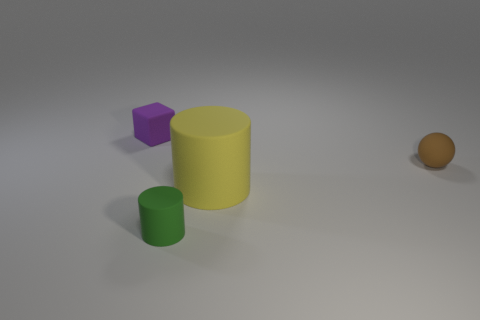Add 3 yellow cylinders. How many objects exist? 7 Subtract all yellow cylinders. How many cylinders are left? 1 Subtract all cubes. How many objects are left? 3 Subtract 2 cylinders. How many cylinders are left? 0 Subtract all yellow blocks. Subtract all cyan spheres. How many blocks are left? 1 Subtract all cyan spheres. How many green cylinders are left? 1 Subtract all large matte objects. Subtract all large red matte objects. How many objects are left? 3 Add 1 matte cylinders. How many matte cylinders are left? 3 Add 2 tiny green rubber things. How many tiny green rubber things exist? 3 Subtract 0 yellow cubes. How many objects are left? 4 